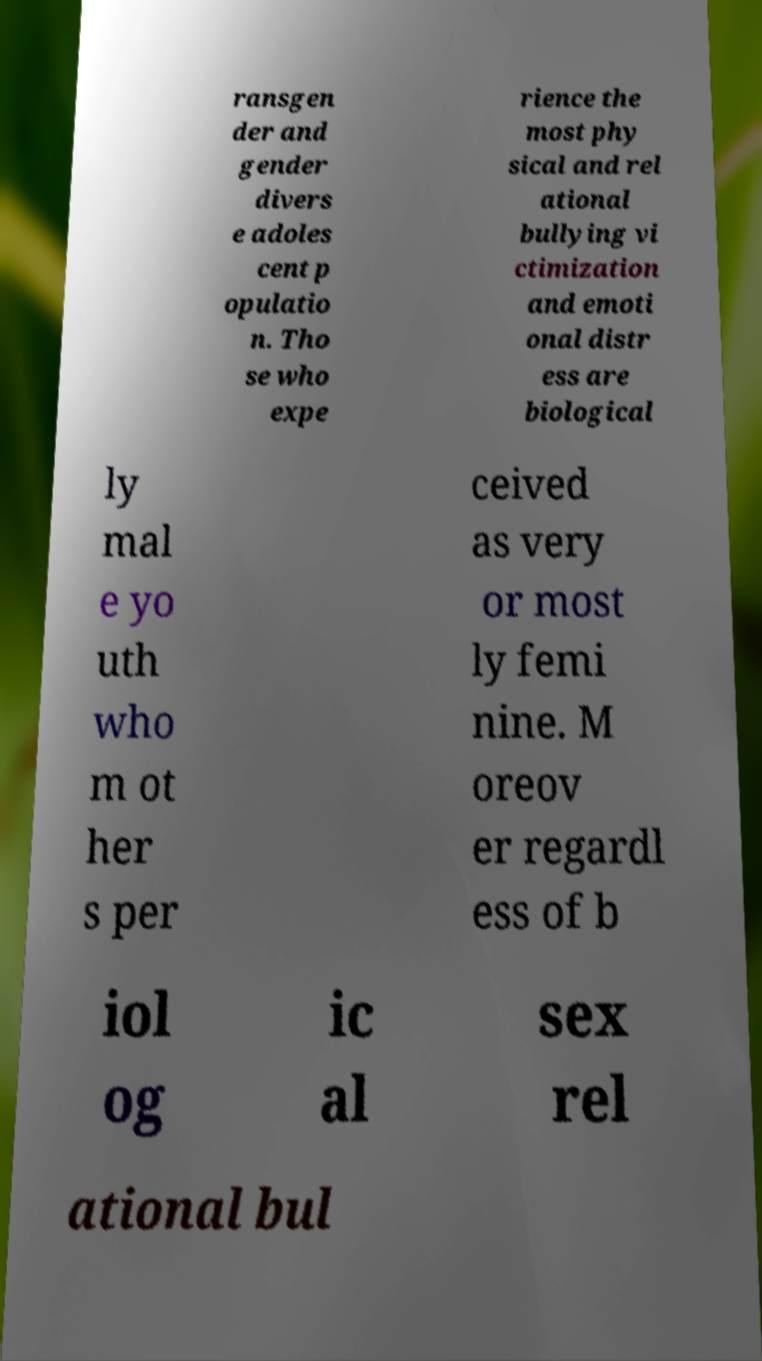Can you read and provide the text displayed in the image?This photo seems to have some interesting text. Can you extract and type it out for me? ransgen der and gender divers e adoles cent p opulatio n. Tho se who expe rience the most phy sical and rel ational bullying vi ctimization and emoti onal distr ess are biological ly mal e yo uth who m ot her s per ceived as very or most ly femi nine. M oreov er regardl ess of b iol og ic al sex rel ational bul 